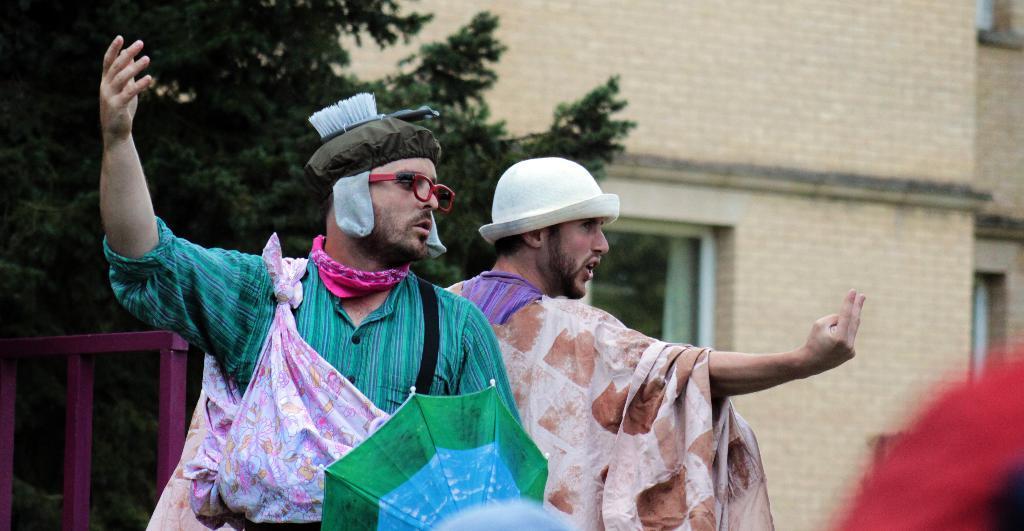Could you give a brief overview of what you see in this image? There are two persons in different color dresses, one of them is holding an umbrella. On the right side, there is a red color object. In the background, there is a tree near a building which is having glass windows. 